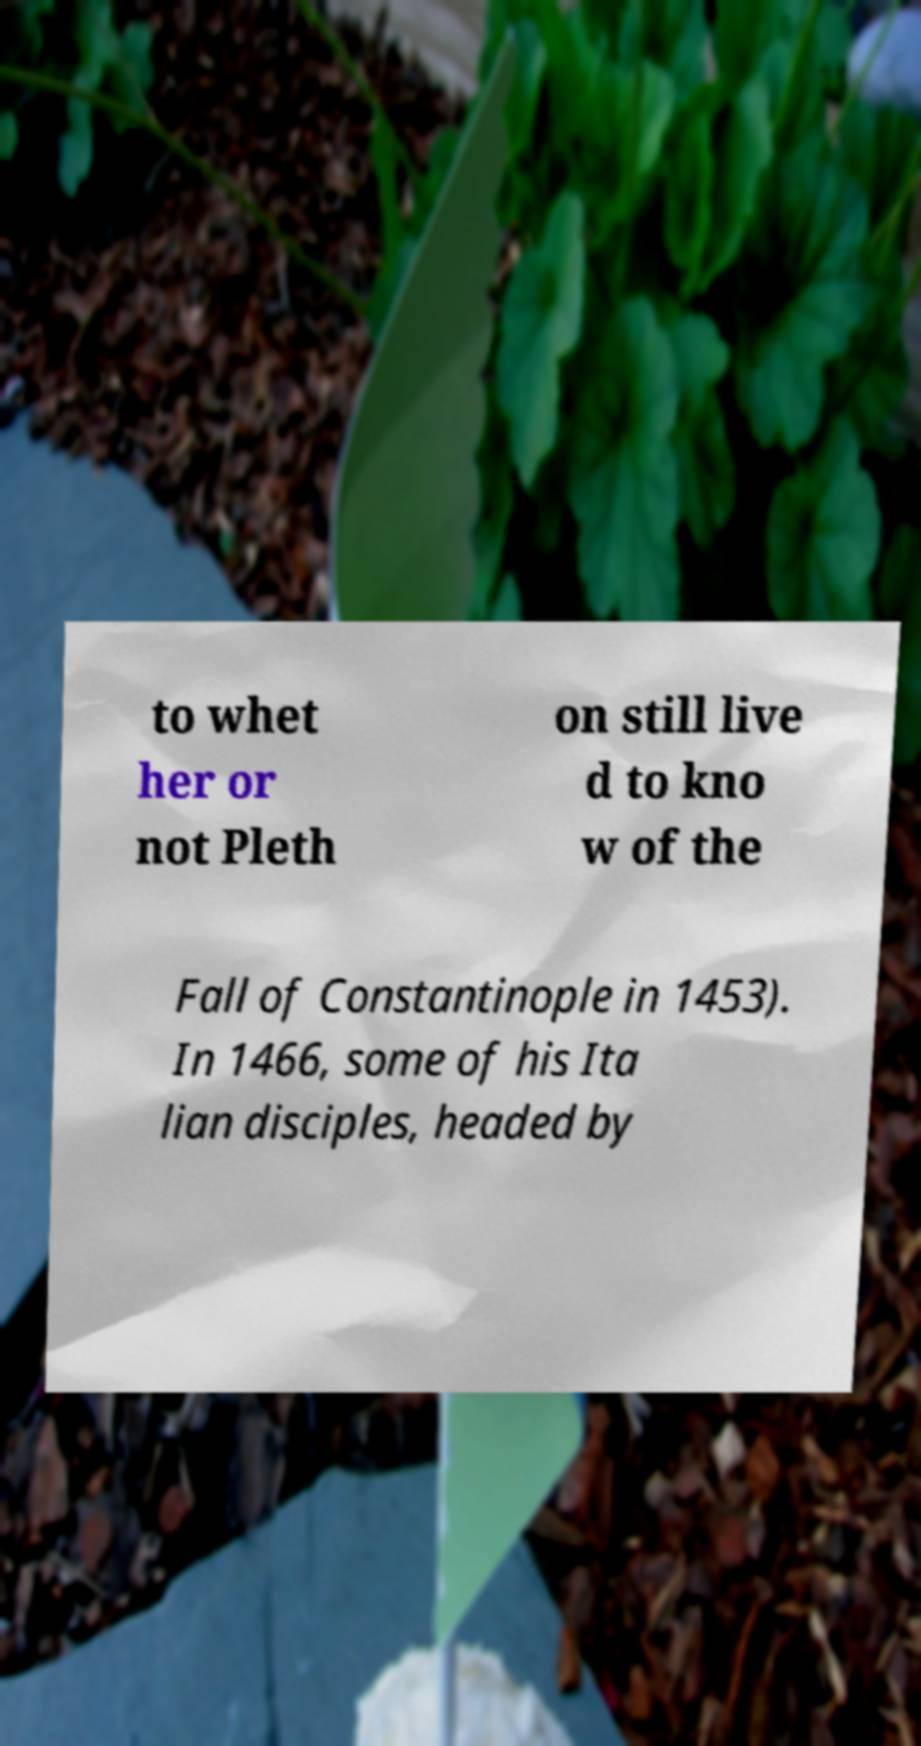I need the written content from this picture converted into text. Can you do that? to whet her or not Pleth on still live d to kno w of the Fall of Constantinople in 1453). In 1466, some of his Ita lian disciples, headed by 